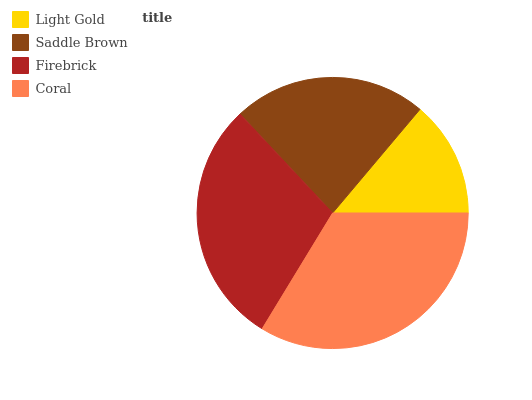Is Light Gold the minimum?
Answer yes or no. Yes. Is Coral the maximum?
Answer yes or no. Yes. Is Saddle Brown the minimum?
Answer yes or no. No. Is Saddle Brown the maximum?
Answer yes or no. No. Is Saddle Brown greater than Light Gold?
Answer yes or no. Yes. Is Light Gold less than Saddle Brown?
Answer yes or no. Yes. Is Light Gold greater than Saddle Brown?
Answer yes or no. No. Is Saddle Brown less than Light Gold?
Answer yes or no. No. Is Firebrick the high median?
Answer yes or no. Yes. Is Saddle Brown the low median?
Answer yes or no. Yes. Is Light Gold the high median?
Answer yes or no. No. Is Coral the low median?
Answer yes or no. No. 